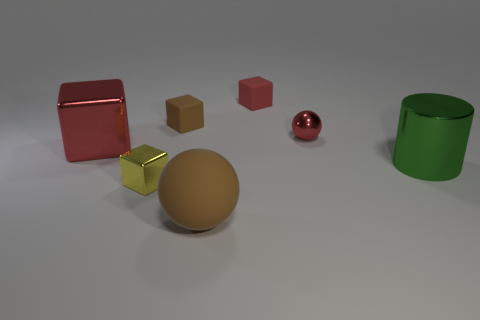Are there fewer big gray shiny cubes than balls?
Make the answer very short. Yes. What shape is the brown thing that is on the right side of the brown object behind the matte thing in front of the large green thing?
Your response must be concise. Sphere. What number of things are tiny blocks that are behind the small yellow metal cube or large things on the right side of the yellow metal object?
Offer a very short reply. 4. Are there any brown balls behind the large red block?
Provide a succinct answer. No. How many things are either tiny cubes that are in front of the large red cube or small brown things?
Your answer should be very brief. 2. How many purple objects are big shiny things or small metal cylinders?
Provide a short and direct response. 0. How many other things are there of the same color as the large rubber ball?
Give a very brief answer. 1. Are there fewer big brown rubber balls that are behind the small yellow metallic block than red rubber objects?
Provide a short and direct response. Yes. There is a small thing that is behind the rubber block left of the tiny cube that is right of the brown sphere; what is its color?
Offer a very short reply. Red. Is there any other thing that has the same material as the small red sphere?
Your response must be concise. Yes. 